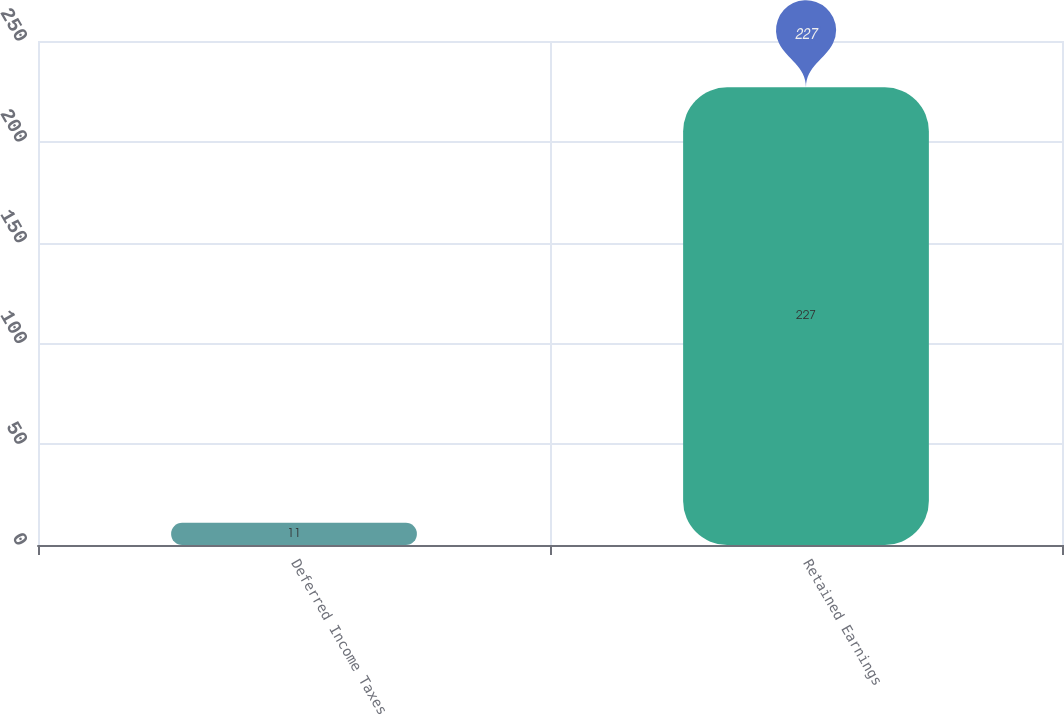<chart> <loc_0><loc_0><loc_500><loc_500><bar_chart><fcel>Deferred Income Taxes<fcel>Retained Earnings<nl><fcel>11<fcel>227<nl></chart> 